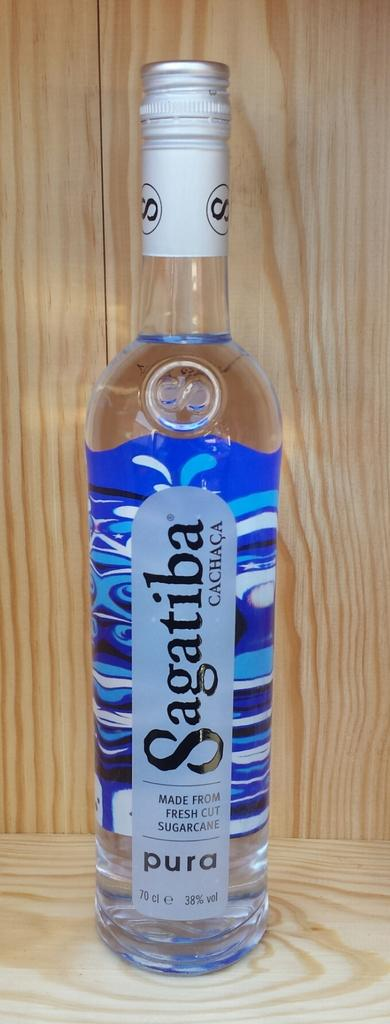What type of setting is depicted in the image? The image is of an indoor setting. What is the main object in the center of the image? There is a sealed glass bottle in the center of the image. Where is the bottle placed in the image? The bottle is placed on top of a surface. What material can be seen in the background of the image? There is wood visible in the background of the image. Can you see any pipes or quicksand in the image? No, there are no pipes or quicksand present in the image. Is there a giraffe visible in the image? No, there is no giraffe present in the image. 